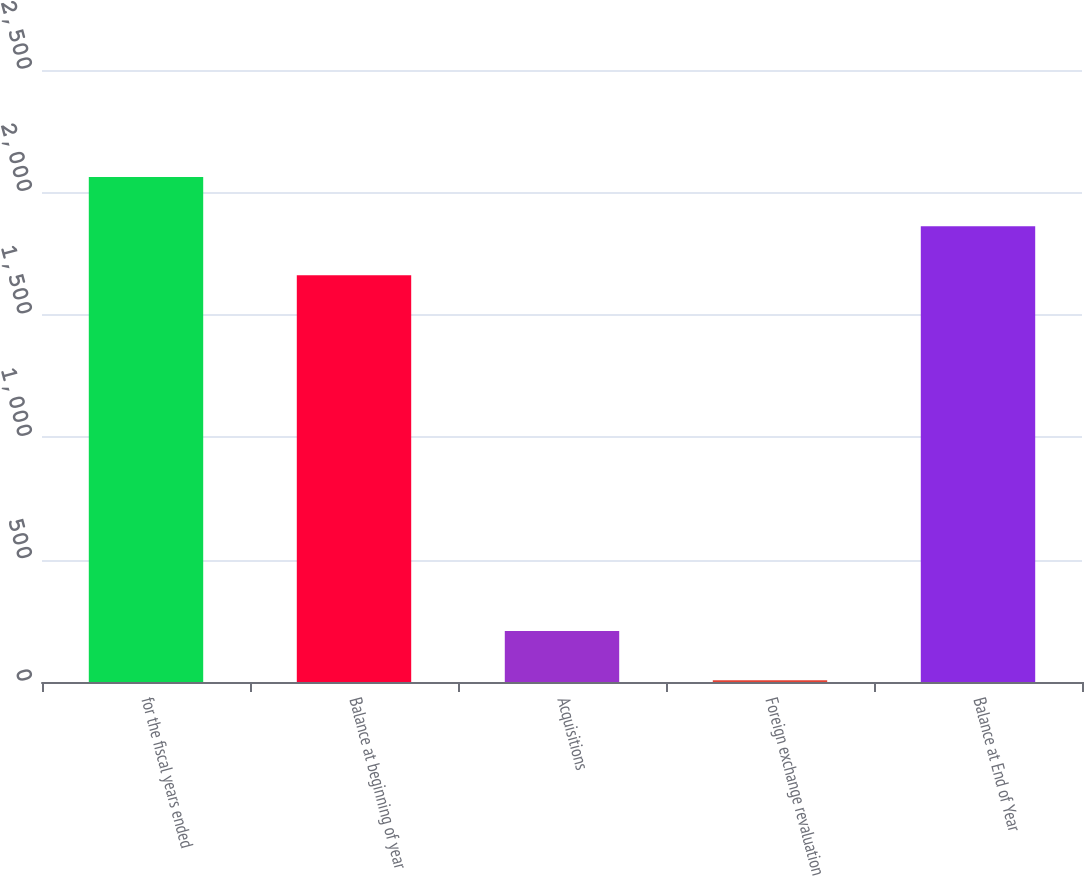Convert chart. <chart><loc_0><loc_0><loc_500><loc_500><bar_chart><fcel>for the fiscal years ended<fcel>Balance at beginning of year<fcel>Acquisitions<fcel>Foreign exchange revaluation<fcel>Balance at End of Year<nl><fcel>2063.16<fcel>1661.2<fcel>208.18<fcel>7.2<fcel>1862.18<nl></chart> 